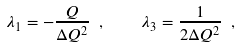<formula> <loc_0><loc_0><loc_500><loc_500>\lambda _ { 1 } = - \frac { Q } { \Delta Q ^ { 2 } } \ , \quad \lambda _ { 3 } = \frac { 1 } { 2 \Delta Q ^ { 2 } } \ ,</formula> 